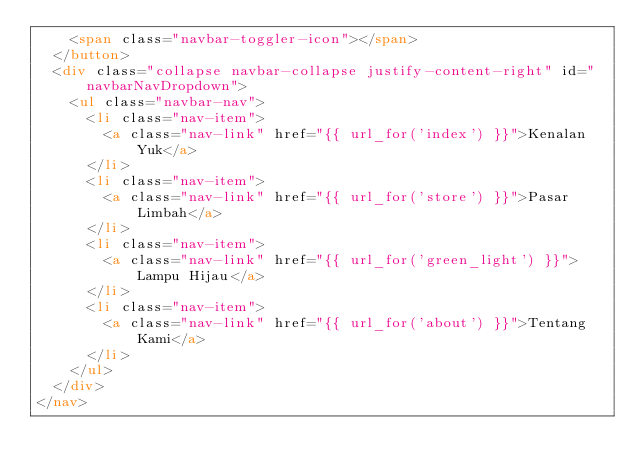<code> <loc_0><loc_0><loc_500><loc_500><_HTML_>    <span class="navbar-toggler-icon"></span>
  </button>
  <div class="collapse navbar-collapse justify-content-right" id="navbarNavDropdown">
    <ul class="navbar-nav">
      <li class="nav-item">
        <a class="nav-link" href="{{ url_for('index') }}">Kenalan Yuk</a>
      </li>
      <li class="nav-item">
        <a class="nav-link" href="{{ url_for('store') }}">Pasar Limbah</a>
      </li>
      <li class="nav-item">
        <a class="nav-link" href="{{ url_for('green_light') }}">Lampu Hijau</a>
      </li>
      <li class="nav-item">
        <a class="nav-link" href="{{ url_for('about') }}">Tentang Kami</a>
      </li>
    </ul>
  </div>
</nav>
</code> 